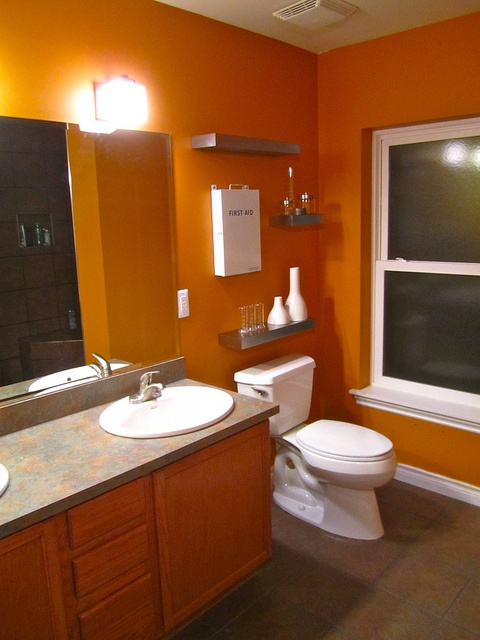Describe the objects in this image and their specific colors. I can see toilet in red, lightgray, gray, darkgray, and maroon tones, sink in red, white, darkgray, and gray tones, vase in red, lightgray, pink, gray, and maroon tones, vase in red, white, tan, and gray tones, and cup in red, brown, salmon, tan, and darkgray tones in this image. 